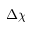Convert formula to latex. <formula><loc_0><loc_0><loc_500><loc_500>\Delta \chi</formula> 